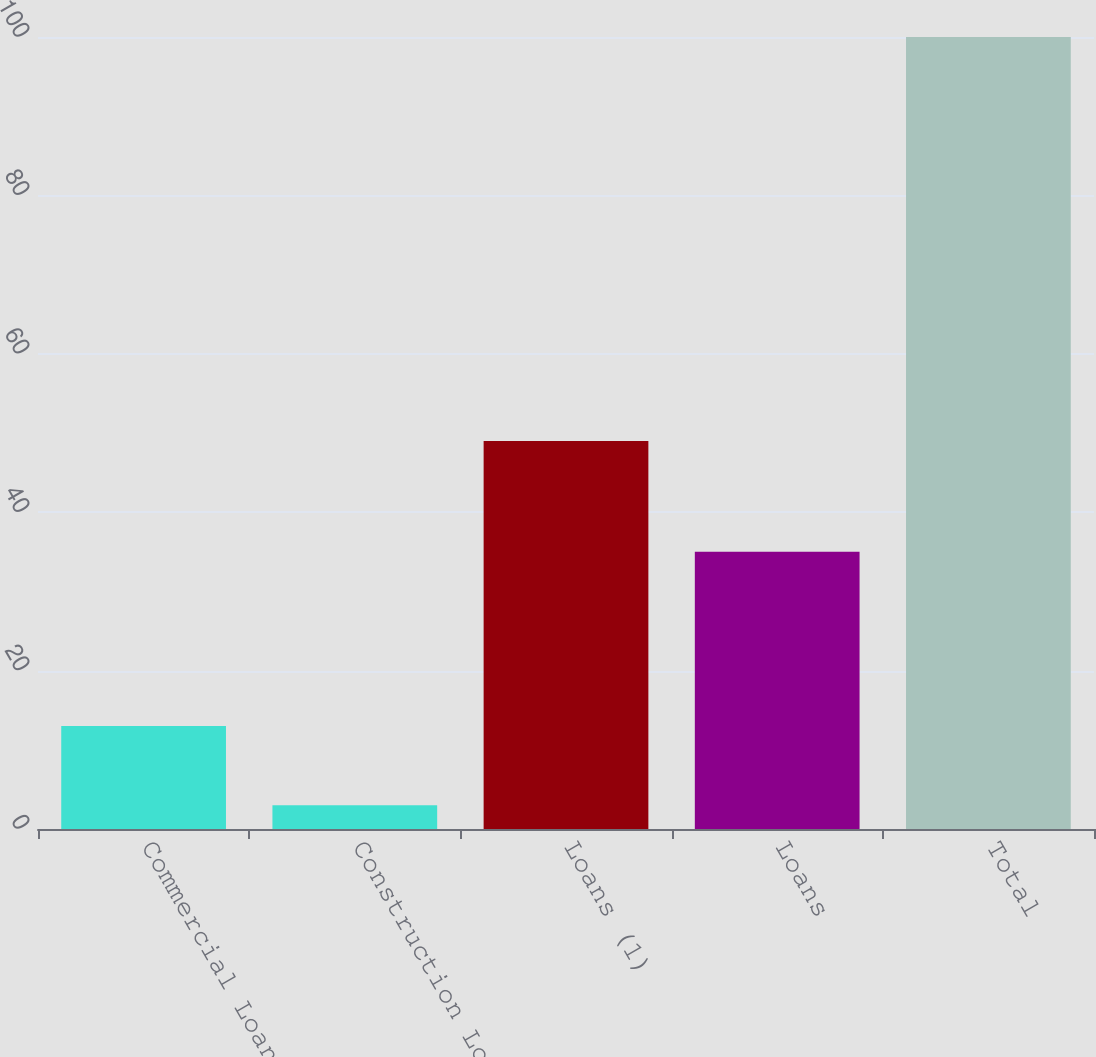<chart> <loc_0><loc_0><loc_500><loc_500><bar_chart><fcel>Commercial Loans<fcel>Construction Loans<fcel>Loans (1)<fcel>Loans<fcel>Total<nl><fcel>13<fcel>3<fcel>49<fcel>35<fcel>100<nl></chart> 